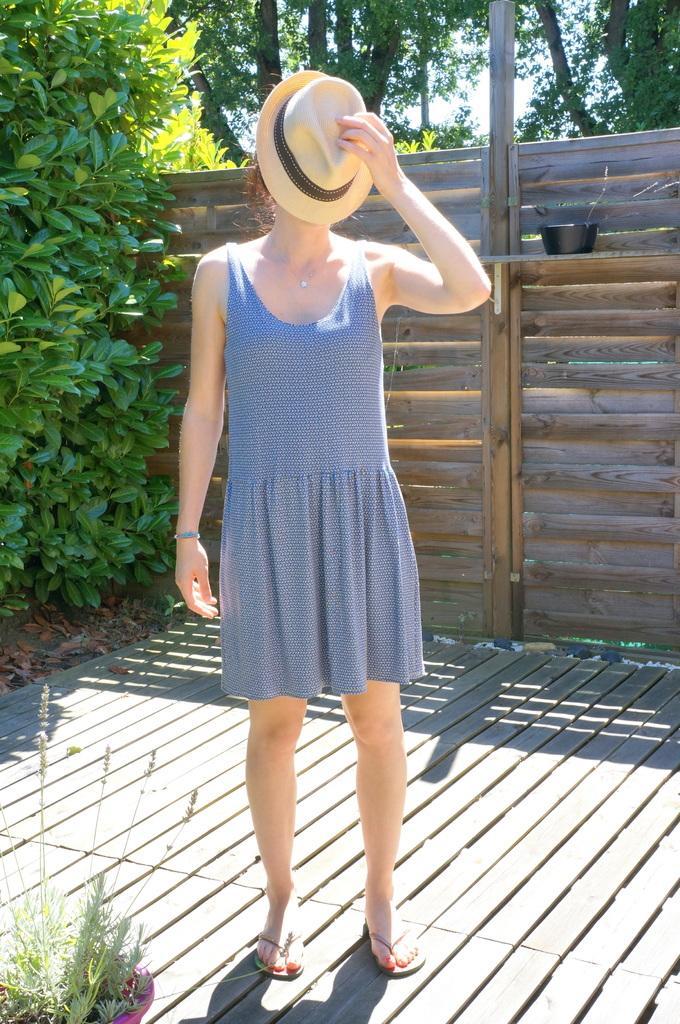Can you describe this image briefly? In this picture we can see a woman standing on the ground, she is holding a hat, here we can see a house plant and in the background we can see a fence, trees, sky. 